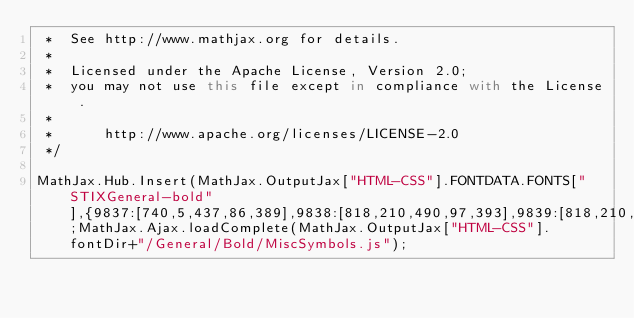<code> <loc_0><loc_0><loc_500><loc_500><_JavaScript_> *  See http://www.mathjax.org for details.
 * 
 *  Licensed under the Apache License, Version 2.0;
 *  you may not use this file except in compliance with the License.
 *
 *      http://www.apache.org/licenses/LICENSE-2.0
 */

MathJax.Hub.Insert(MathJax.OutputJax["HTML-CSS"].FONTDATA.FONTS["STIXGeneral-bold"],{9837:[740,5,437,86,389],9838:[818,210,490,97,393],9839:[818,210,490,52,438]});MathJax.Ajax.loadComplete(MathJax.OutputJax["HTML-CSS"].fontDir+"/General/Bold/MiscSymbols.js");

</code> 